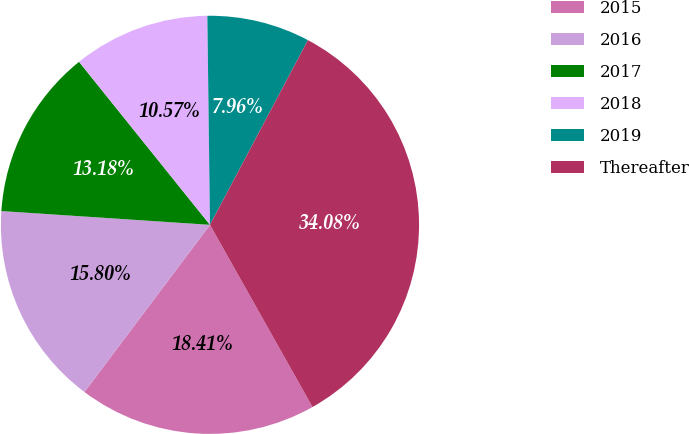Convert chart. <chart><loc_0><loc_0><loc_500><loc_500><pie_chart><fcel>2015<fcel>2016<fcel>2017<fcel>2018<fcel>2019<fcel>Thereafter<nl><fcel>18.41%<fcel>15.8%<fcel>13.18%<fcel>10.57%<fcel>7.96%<fcel>34.08%<nl></chart> 